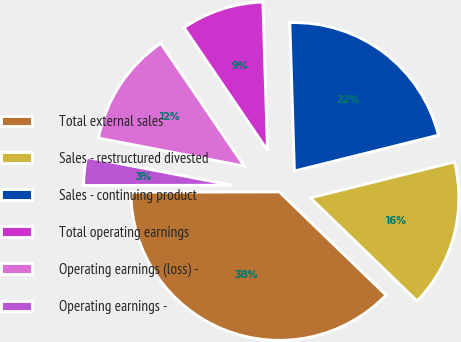Convert chart to OTSL. <chart><loc_0><loc_0><loc_500><loc_500><pie_chart><fcel>Total external sales<fcel>Sales - restructured divested<fcel>Sales - continuing product<fcel>Total operating earnings<fcel>Operating earnings (loss) -<fcel>Operating earnings -<nl><fcel>37.73%<fcel>16.12%<fcel>21.61%<fcel>9.01%<fcel>12.48%<fcel>3.05%<nl></chart> 